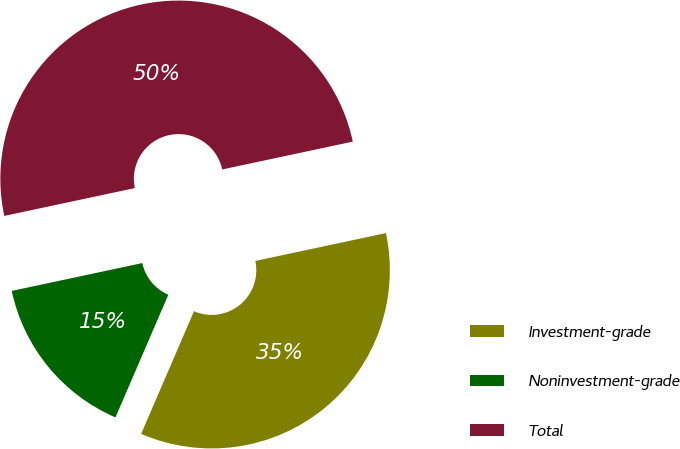<chart> <loc_0><loc_0><loc_500><loc_500><pie_chart><fcel>Investment-grade<fcel>Noninvestment-grade<fcel>Total<nl><fcel>34.82%<fcel>15.18%<fcel>50.0%<nl></chart> 